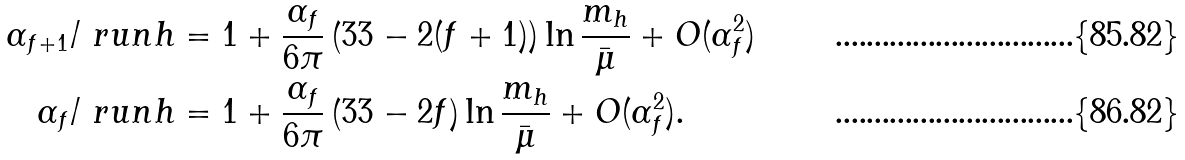<formula> <loc_0><loc_0><loc_500><loc_500>\alpha _ { f + 1 } / \ r u n { h } & = 1 + \frac { \alpha _ { f } } { 6 \pi } \left ( 3 3 - 2 ( f + 1 ) \right ) \ln \frac { m _ { h } } { \bar { \mu } } + O ( \alpha _ { f } ^ { 2 } ) \\ \alpha _ { f } / \ r u n { h } & = 1 + \frac { \alpha _ { f } } { 6 \pi } \left ( 3 3 - 2 f \right ) \ln \frac { m _ { h } } { \bar { \mu } } + O ( \alpha _ { f } ^ { 2 } ) .</formula> 